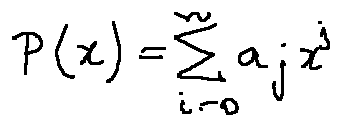Convert formula to latex. <formula><loc_0><loc_0><loc_500><loc_500>P ( x ) = \sum \lim i t s _ { i = 0 } ^ { n } a _ { j } x ^ { j }</formula> 